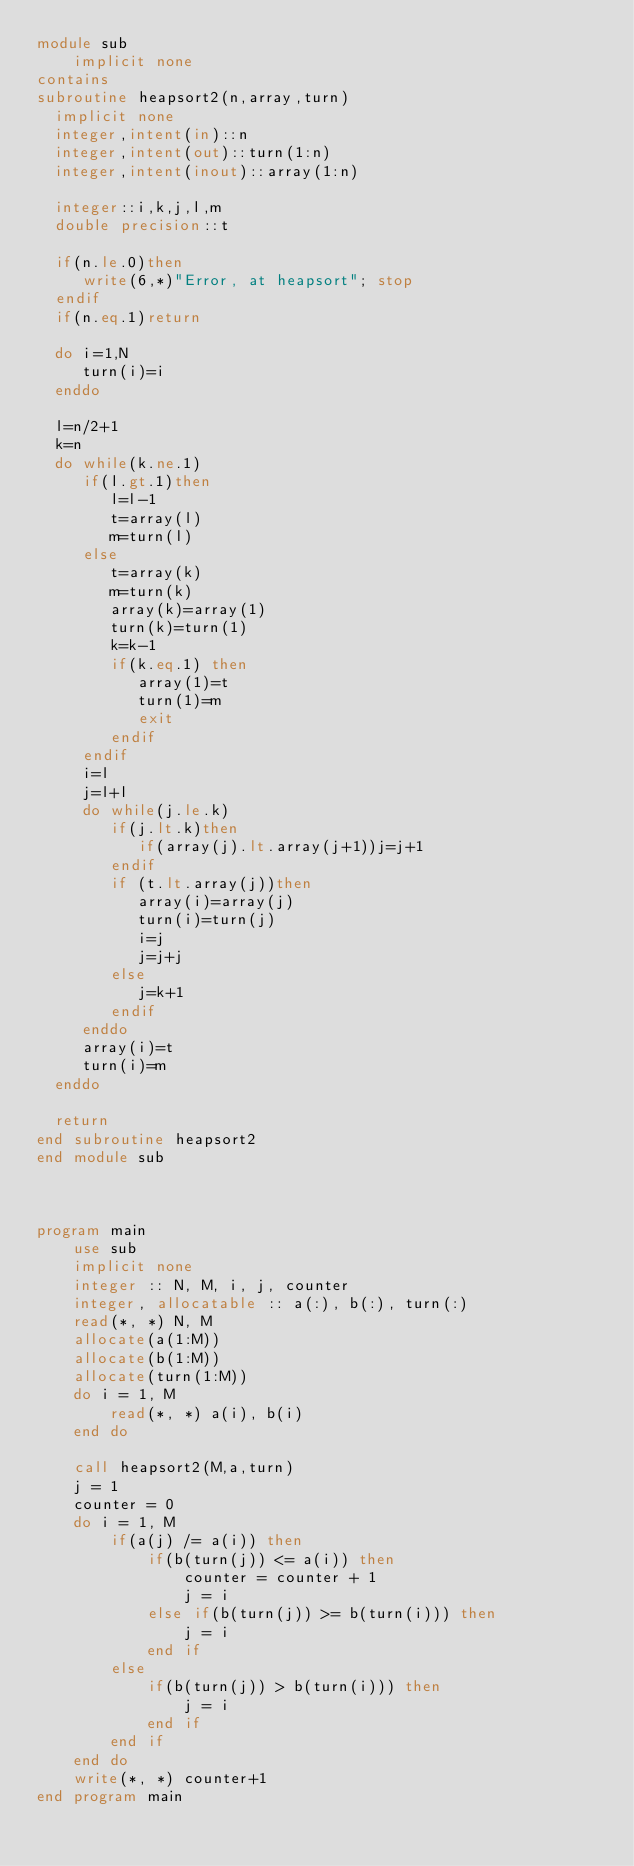Convert code to text. <code><loc_0><loc_0><loc_500><loc_500><_FORTRAN_>module sub
	implicit none
contains
subroutine heapsort2(n,array,turn)
  implicit none
  integer,intent(in)::n
  integer,intent(out)::turn(1:n)
  integer,intent(inout)::array(1:n)
  
  integer::i,k,j,l,m
  double precision::t
  
  if(n.le.0)then
     write(6,*)"Error, at heapsort"; stop
  endif
  if(n.eq.1)return

  do i=1,N
     turn(i)=i
  enddo

  l=n/2+1
  k=n
  do while(k.ne.1)
     if(l.gt.1)then
        l=l-1
        t=array(l)
        m=turn(l)
     else
        t=array(k)
        m=turn(k)
        array(k)=array(1)
        turn(k)=turn(1)
        k=k-1
        if(k.eq.1) then
           array(1)=t
           turn(1)=m
           exit
        endif
     endif
     i=l
     j=l+l
     do while(j.le.k)
        if(j.lt.k)then
           if(array(j).lt.array(j+1))j=j+1
        endif
        if (t.lt.array(j))then
           array(i)=array(j)
           turn(i)=turn(j)
           i=j
           j=j+j
        else
           j=k+1
        endif
     enddo
     array(i)=t
     turn(i)=m
  enddo

  return
end subroutine heapsort2
end module sub



program main
	use sub
	implicit none
	integer :: N, M, i, j, counter
	integer, allocatable :: a(:), b(:), turn(:)
	read(*, *) N, M
	allocate(a(1:M))
	allocate(b(1:M))
	allocate(turn(1:M))
	do i = 1, M
		read(*, *) a(i), b(i)
	end do
	
	call heapsort2(M,a,turn)
	j = 1
	counter = 0
	do i = 1, M
		if(a(j) /= a(i)) then
			if(b(turn(j)) <= a(i)) then
				counter = counter + 1
				j = i
			else if(b(turn(j)) >= b(turn(i))) then
				j = i
			end if
		else
			if(b(turn(j)) > b(turn(i))) then
				j = i
			end if
		end if
	end do
	write(*, *) counter+1
end program main</code> 